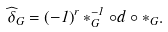<formula> <loc_0><loc_0><loc_500><loc_500>\widehat { \delta } _ { G } = \left ( - 1 \right ) ^ { r } * _ { G } ^ { - 1 } \circ d \circ * _ { G } .</formula> 